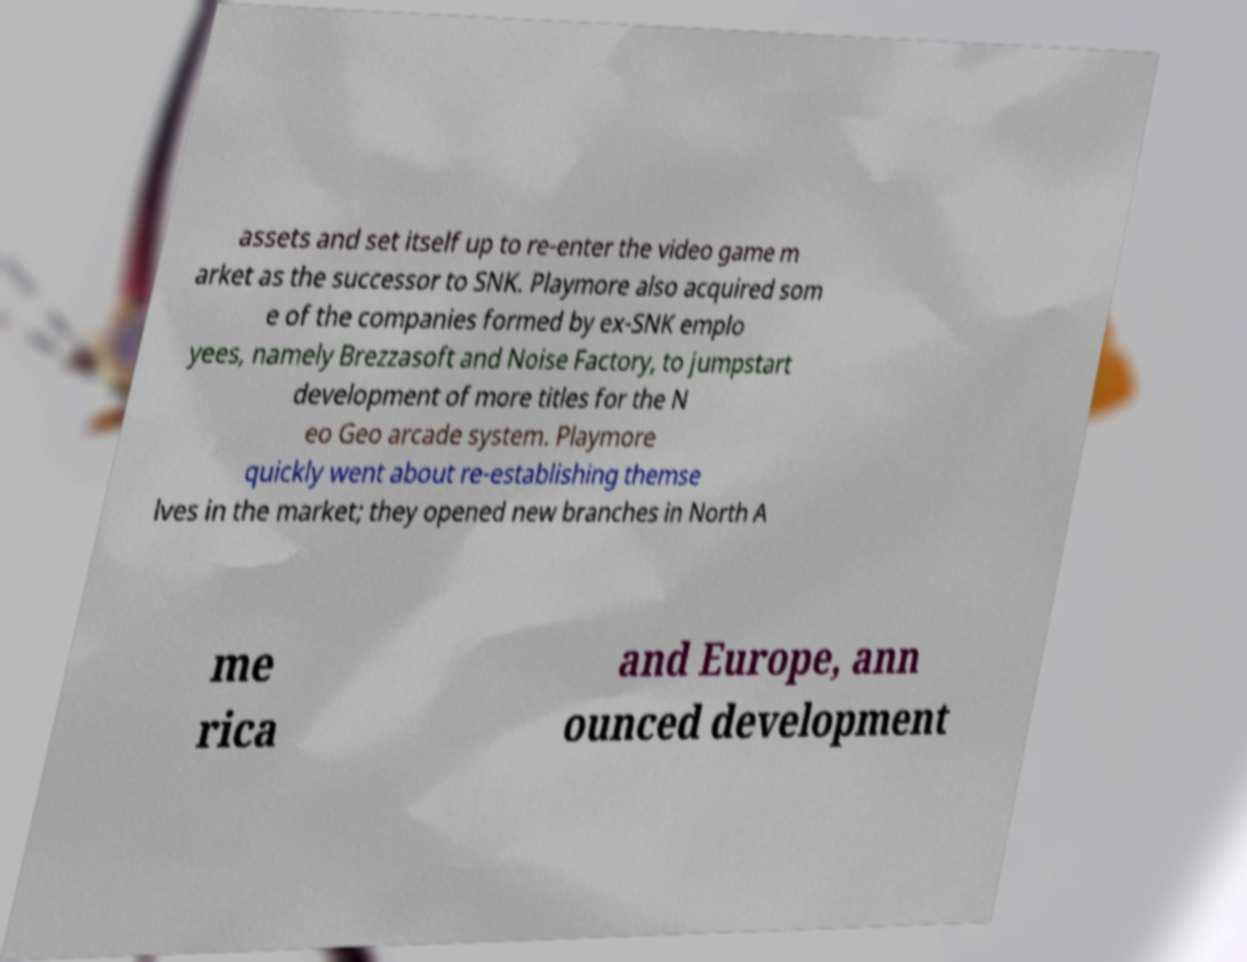Could you assist in decoding the text presented in this image and type it out clearly? assets and set itself up to re-enter the video game m arket as the successor to SNK. Playmore also acquired som e of the companies formed by ex-SNK emplo yees, namely Brezzasoft and Noise Factory, to jumpstart development of more titles for the N eo Geo arcade system. Playmore quickly went about re-establishing themse lves in the market; they opened new branches in North A me rica and Europe, ann ounced development 